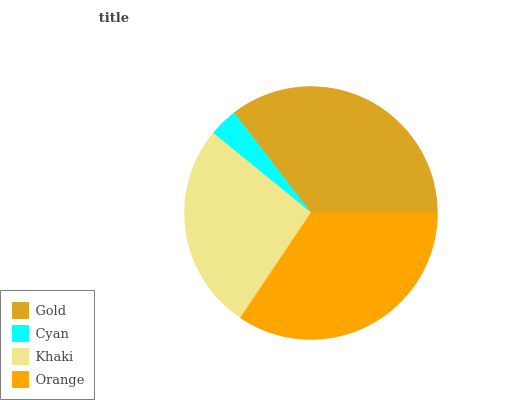Is Cyan the minimum?
Answer yes or no. Yes. Is Gold the maximum?
Answer yes or no. Yes. Is Khaki the minimum?
Answer yes or no. No. Is Khaki the maximum?
Answer yes or no. No. Is Khaki greater than Cyan?
Answer yes or no. Yes. Is Cyan less than Khaki?
Answer yes or no. Yes. Is Cyan greater than Khaki?
Answer yes or no. No. Is Khaki less than Cyan?
Answer yes or no. No. Is Orange the high median?
Answer yes or no. Yes. Is Khaki the low median?
Answer yes or no. Yes. Is Cyan the high median?
Answer yes or no. No. Is Orange the low median?
Answer yes or no. No. 